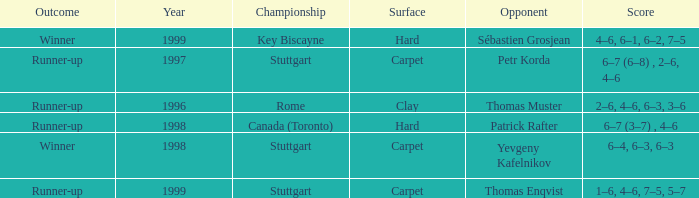How many years was the opponent petr korda? 1.0. 